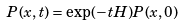Convert formula to latex. <formula><loc_0><loc_0><loc_500><loc_500>P ( x , t ) = \exp ( - t H ) P ( x , 0 )</formula> 